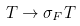Convert formula to latex. <formula><loc_0><loc_0><loc_500><loc_500>T \rightarrow \sigma _ { F } T</formula> 